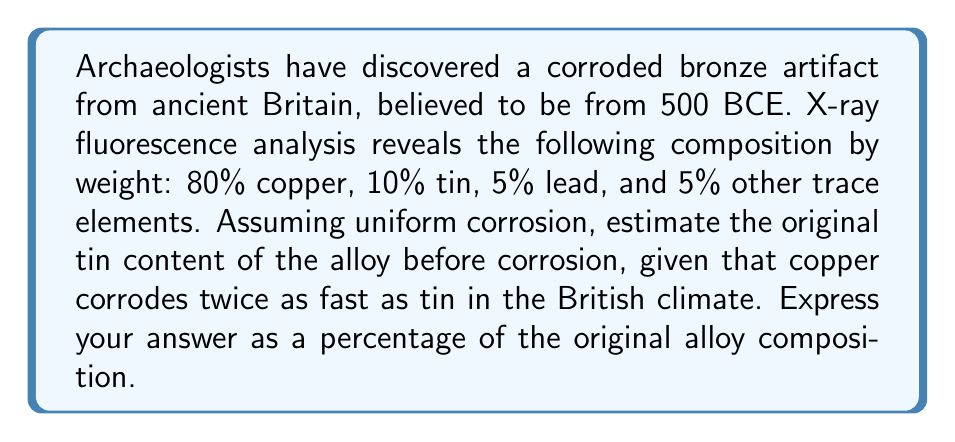Could you help me with this problem? Let's approach this step-by-step:

1) First, we need to understand what the corrosion process means for our composition:
   - Copper corrodes twice as fast as tin
   - Other elements (lead and trace elements) are assumed to corrode at an unknown rate

2) Let's denote the original composition as follows:
   $x$ = original percentage of copper
   $y$ = original percentage of tin
   $z$ = original percentage of other elements (lead + trace)

3) We can set up an equation based on the corrosion rates:
   $\frac{80}{x} = 2 \cdot \frac{10}{y}$

4) We also know that the original percentages must sum to 100%:
   $x + y + z = 100$

5) From the given data, we can assume $z = 10$ (5% lead + 5% trace elements)

6) Substituting this into our sum equation:
   $x + y + 10 = 100$
   $x + y = 90$

7) From our corrosion rate equation:
   $\frac{80}{x} = \frac{20}{y}$
   $80y = 20x$
   $4y = x$

8) Substituting this into our sum equation:
   $4y + y = 90$
   $5y = 90$
   $y = 18$

9) Therefore, the original tin content was 18% of the alloy.
Answer: 18% 